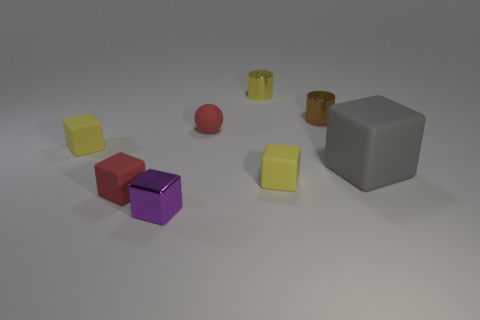Are there any big blue spheres that have the same material as the red sphere? Based on the image provided, there aren't any big blue spheres at all. All the spheres in the image are red, and there is only one in view. The red sphere appears to have a matte finish, similar to some of the other objects in the scene. 